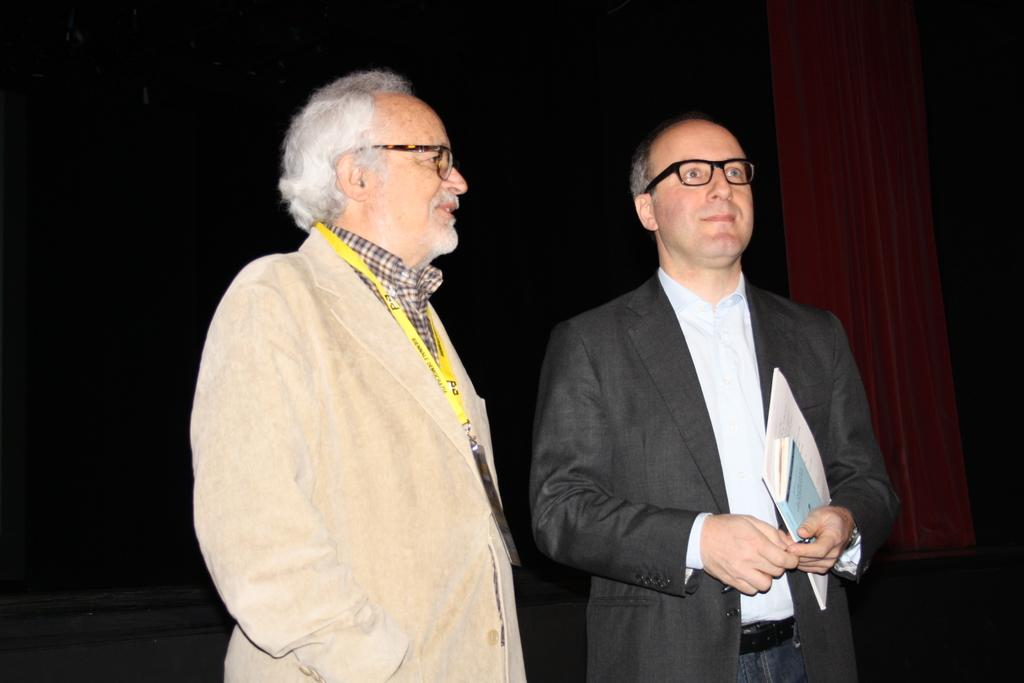How many people are in the image? There are two people standing in the center of the image. What are the people wearing? Both people are wearing suits. What is the man on the right holding in his hand? The man standing on the right is holding books and a pen in his hand. Can you see a toothbrush in the image? No, there is no toothbrush present in the image. What type of field can be seen in the background of the image? There is no field visible in the image; it only shows two people standing in the center. 